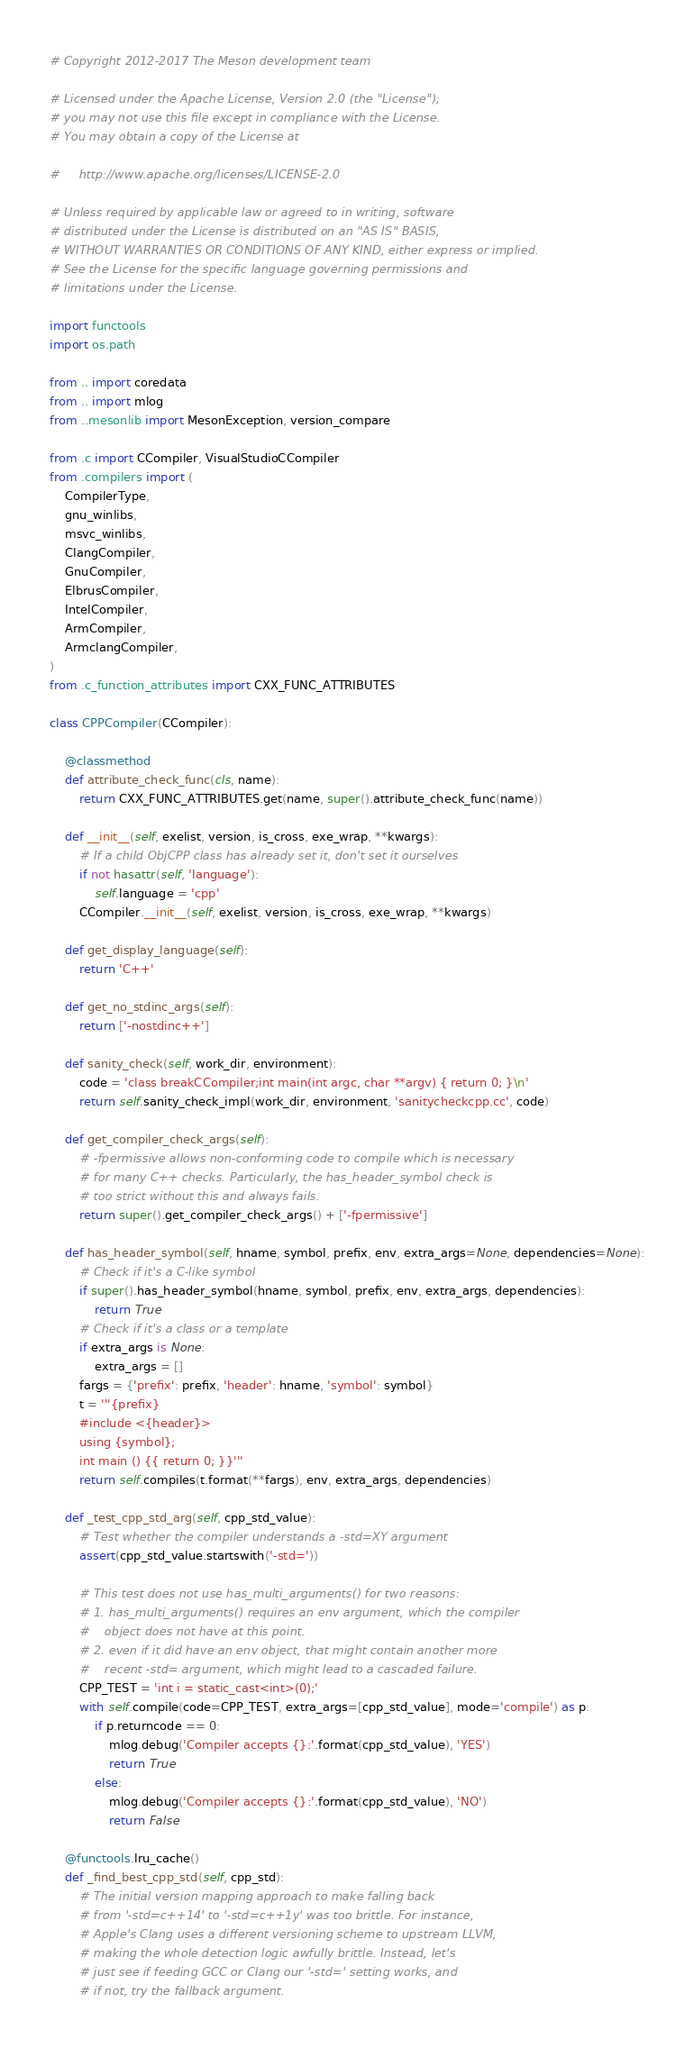<code> <loc_0><loc_0><loc_500><loc_500><_Python_># Copyright 2012-2017 The Meson development team

# Licensed under the Apache License, Version 2.0 (the "License");
# you may not use this file except in compliance with the License.
# You may obtain a copy of the License at

#     http://www.apache.org/licenses/LICENSE-2.0

# Unless required by applicable law or agreed to in writing, software
# distributed under the License is distributed on an "AS IS" BASIS,
# WITHOUT WARRANTIES OR CONDITIONS OF ANY KIND, either express or implied.
# See the License for the specific language governing permissions and
# limitations under the License.

import functools
import os.path

from .. import coredata
from .. import mlog
from ..mesonlib import MesonException, version_compare

from .c import CCompiler, VisualStudioCCompiler
from .compilers import (
    CompilerType,
    gnu_winlibs,
    msvc_winlibs,
    ClangCompiler,
    GnuCompiler,
    ElbrusCompiler,
    IntelCompiler,
    ArmCompiler,
    ArmclangCompiler,
)
from .c_function_attributes import CXX_FUNC_ATTRIBUTES

class CPPCompiler(CCompiler):

    @classmethod
    def attribute_check_func(cls, name):
        return CXX_FUNC_ATTRIBUTES.get(name, super().attribute_check_func(name))

    def __init__(self, exelist, version, is_cross, exe_wrap, **kwargs):
        # If a child ObjCPP class has already set it, don't set it ourselves
        if not hasattr(self, 'language'):
            self.language = 'cpp'
        CCompiler.__init__(self, exelist, version, is_cross, exe_wrap, **kwargs)

    def get_display_language(self):
        return 'C++'

    def get_no_stdinc_args(self):
        return ['-nostdinc++']

    def sanity_check(self, work_dir, environment):
        code = 'class breakCCompiler;int main(int argc, char **argv) { return 0; }\n'
        return self.sanity_check_impl(work_dir, environment, 'sanitycheckcpp.cc', code)

    def get_compiler_check_args(self):
        # -fpermissive allows non-conforming code to compile which is necessary
        # for many C++ checks. Particularly, the has_header_symbol check is
        # too strict without this and always fails.
        return super().get_compiler_check_args() + ['-fpermissive']

    def has_header_symbol(self, hname, symbol, prefix, env, extra_args=None, dependencies=None):
        # Check if it's a C-like symbol
        if super().has_header_symbol(hname, symbol, prefix, env, extra_args, dependencies):
            return True
        # Check if it's a class or a template
        if extra_args is None:
            extra_args = []
        fargs = {'prefix': prefix, 'header': hname, 'symbol': symbol}
        t = '''{prefix}
        #include <{header}>
        using {symbol};
        int main () {{ return 0; }}'''
        return self.compiles(t.format(**fargs), env, extra_args, dependencies)

    def _test_cpp_std_arg(self, cpp_std_value):
        # Test whether the compiler understands a -std=XY argument
        assert(cpp_std_value.startswith('-std='))

        # This test does not use has_multi_arguments() for two reasons:
        # 1. has_multi_arguments() requires an env argument, which the compiler
        #    object does not have at this point.
        # 2. even if it did have an env object, that might contain another more
        #    recent -std= argument, which might lead to a cascaded failure.
        CPP_TEST = 'int i = static_cast<int>(0);'
        with self.compile(code=CPP_TEST, extra_args=[cpp_std_value], mode='compile') as p:
            if p.returncode == 0:
                mlog.debug('Compiler accepts {}:'.format(cpp_std_value), 'YES')
                return True
            else:
                mlog.debug('Compiler accepts {}:'.format(cpp_std_value), 'NO')
                return False

    @functools.lru_cache()
    def _find_best_cpp_std(self, cpp_std):
        # The initial version mapping approach to make falling back
        # from '-std=c++14' to '-std=c++1y' was too brittle. For instance,
        # Apple's Clang uses a different versioning scheme to upstream LLVM,
        # making the whole detection logic awfully brittle. Instead, let's
        # just see if feeding GCC or Clang our '-std=' setting works, and
        # if not, try the fallback argument.</code> 